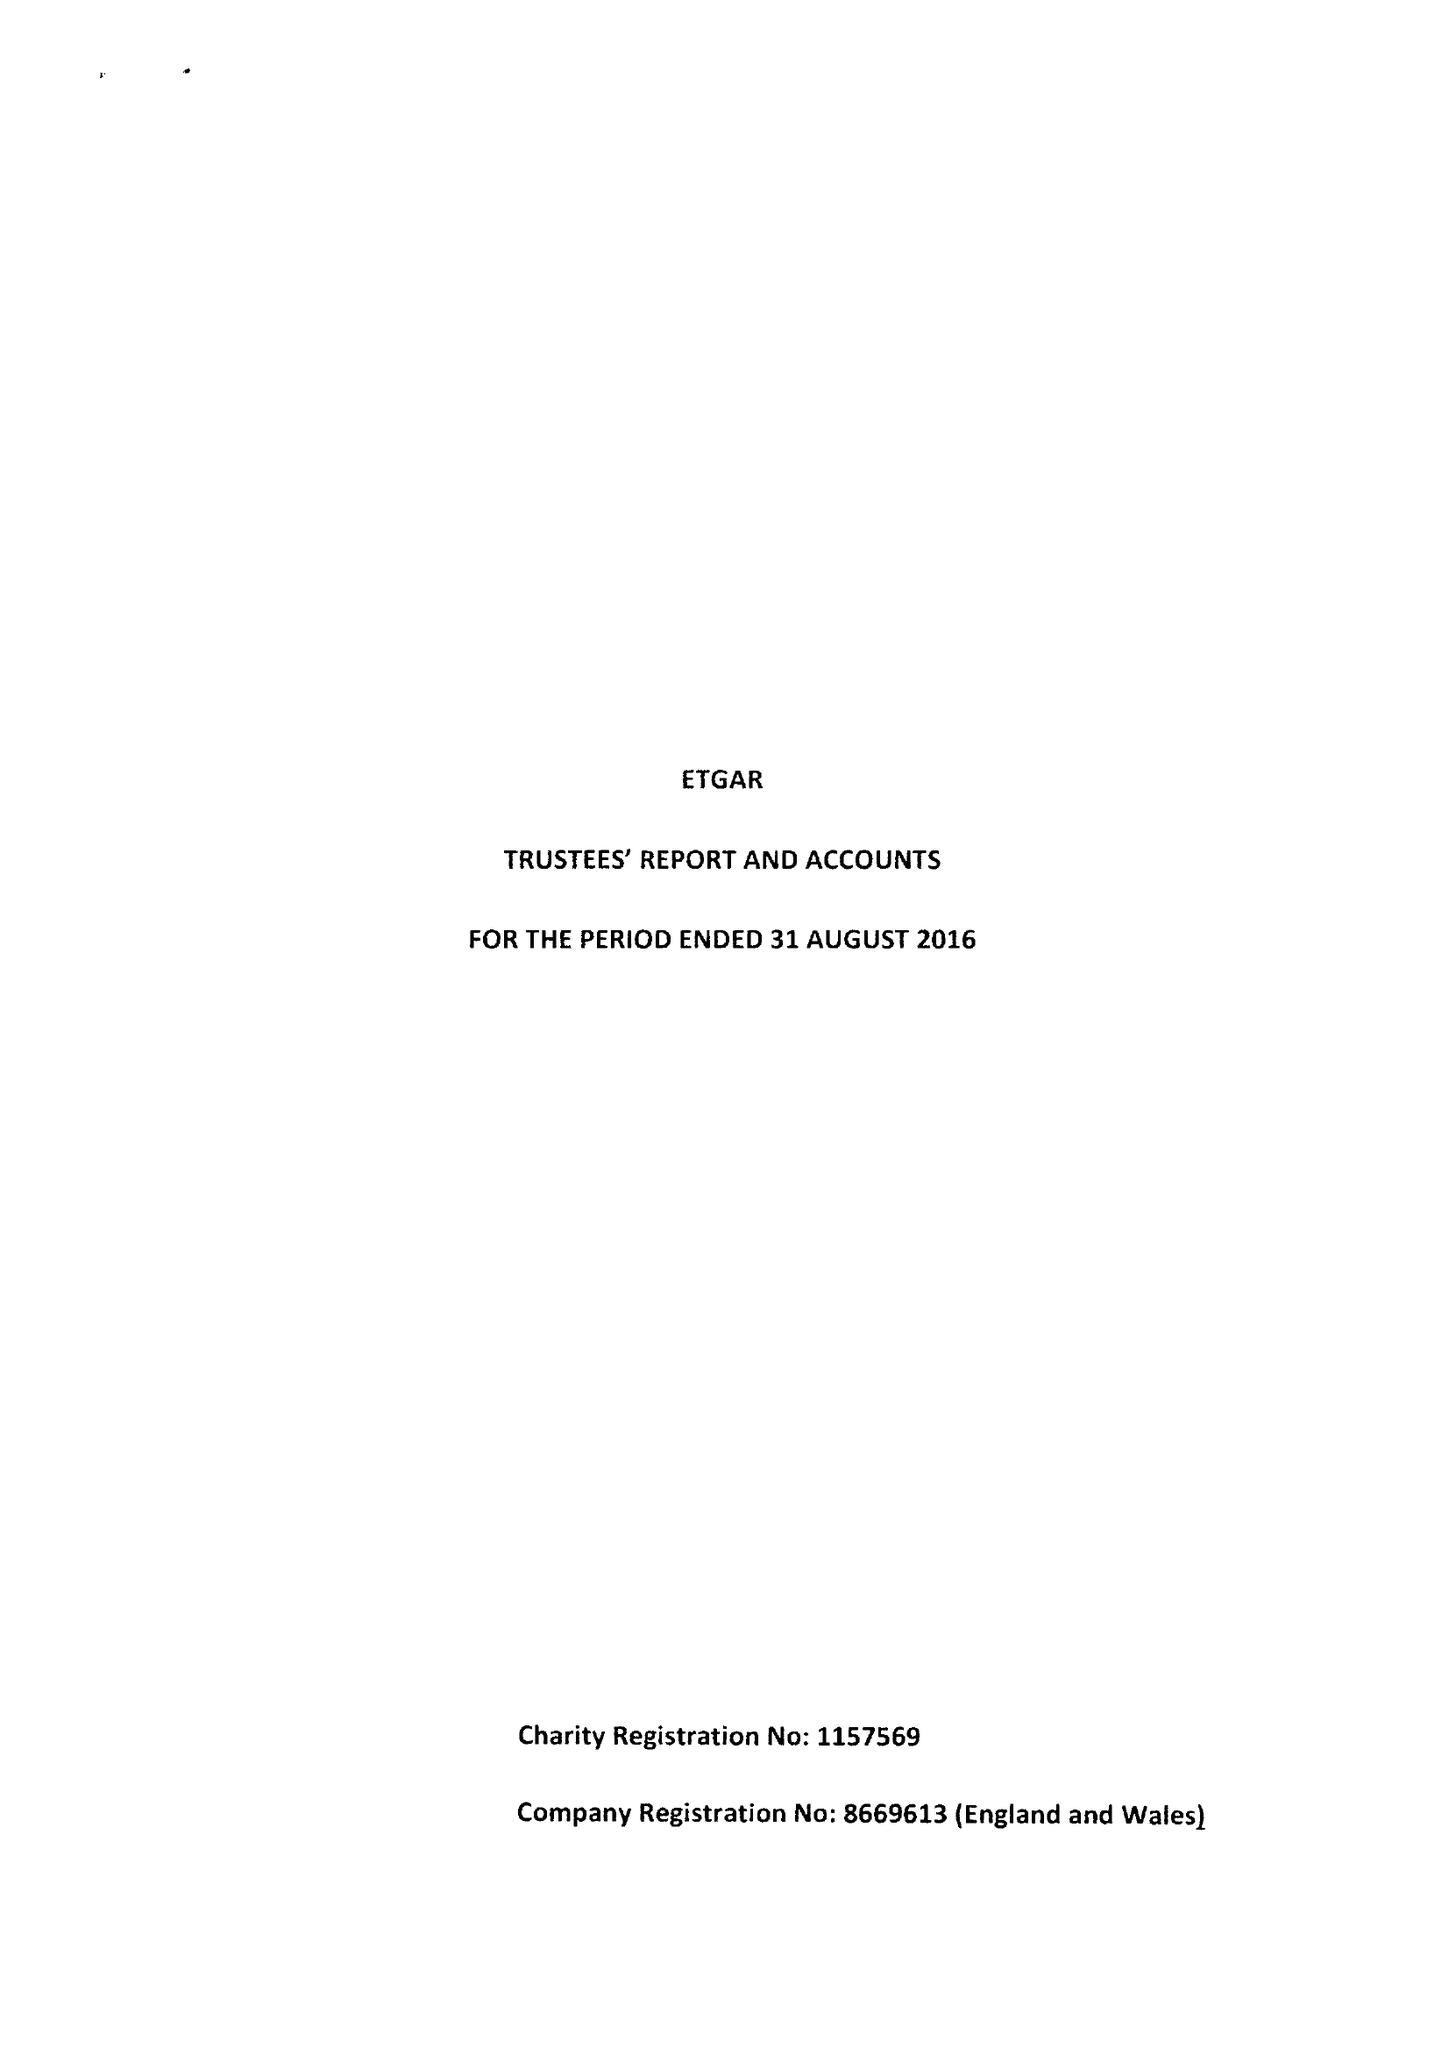What is the value for the address__postcode?
Answer the question using a single word or phrase. EC2A 4RR 